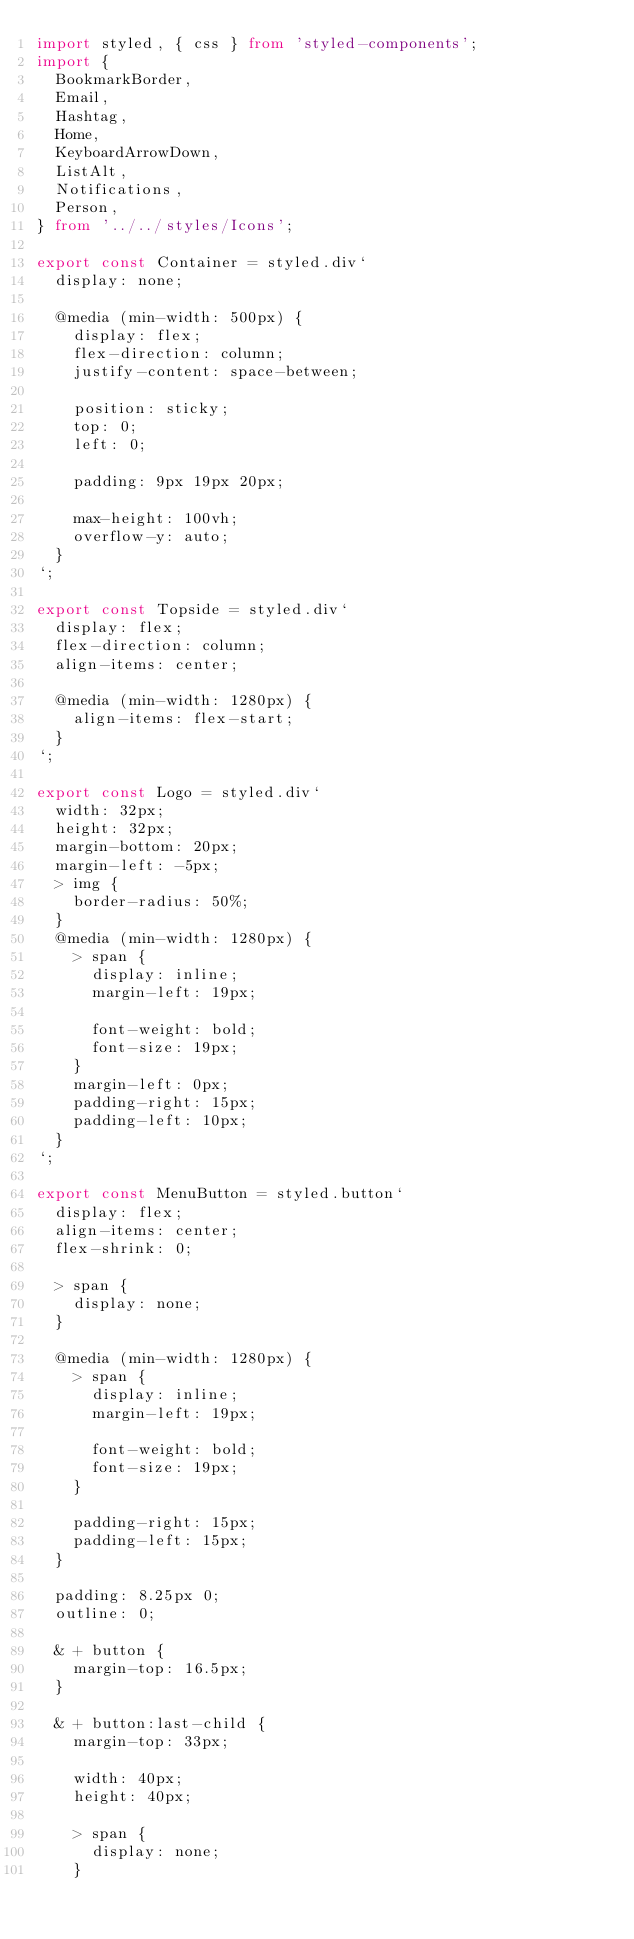Convert code to text. <code><loc_0><loc_0><loc_500><loc_500><_TypeScript_>import styled, { css } from 'styled-components';
import {
  BookmarkBorder,
  Email,
  Hashtag,
  Home,
  KeyboardArrowDown,
  ListAlt,
  Notifications,
  Person,
} from '../../styles/Icons';

export const Container = styled.div`
  display: none;

  @media (min-width: 500px) {
    display: flex;
    flex-direction: column;
    justify-content: space-between;

    position: sticky;
    top: 0;
    left: 0;

    padding: 9px 19px 20px;

    max-height: 100vh;
    overflow-y: auto;
  }
`;

export const Topside = styled.div`
  display: flex;
  flex-direction: column;
  align-items: center;

  @media (min-width: 1280px) {
    align-items: flex-start;
  }
`;

export const Logo = styled.div`
  width: 32px;
  height: 32px;
  margin-bottom: 20px;
  margin-left: -5px;
  > img {
    border-radius: 50%;
  }
  @media (min-width: 1280px) {
    > span {
      display: inline;
      margin-left: 19px;

      font-weight: bold;
      font-size: 19px;
    }
    margin-left: 0px;
    padding-right: 15px;
    padding-left: 10px;
  }
`;

export const MenuButton = styled.button`
  display: flex;
  align-items: center;
  flex-shrink: 0;

  > span {
    display: none;
  }

  @media (min-width: 1280px) {
    > span {
      display: inline;
      margin-left: 19px;

      font-weight: bold;
      font-size: 19px;
    }

    padding-right: 15px;
    padding-left: 15px;
  }

  padding: 8.25px 0;
  outline: 0;

  & + button {
    margin-top: 16.5px;
  }

  & + button:last-child {
    margin-top: 33px;

    width: 40px;
    height: 40px;

    > span {
      display: none;
    }
</code> 